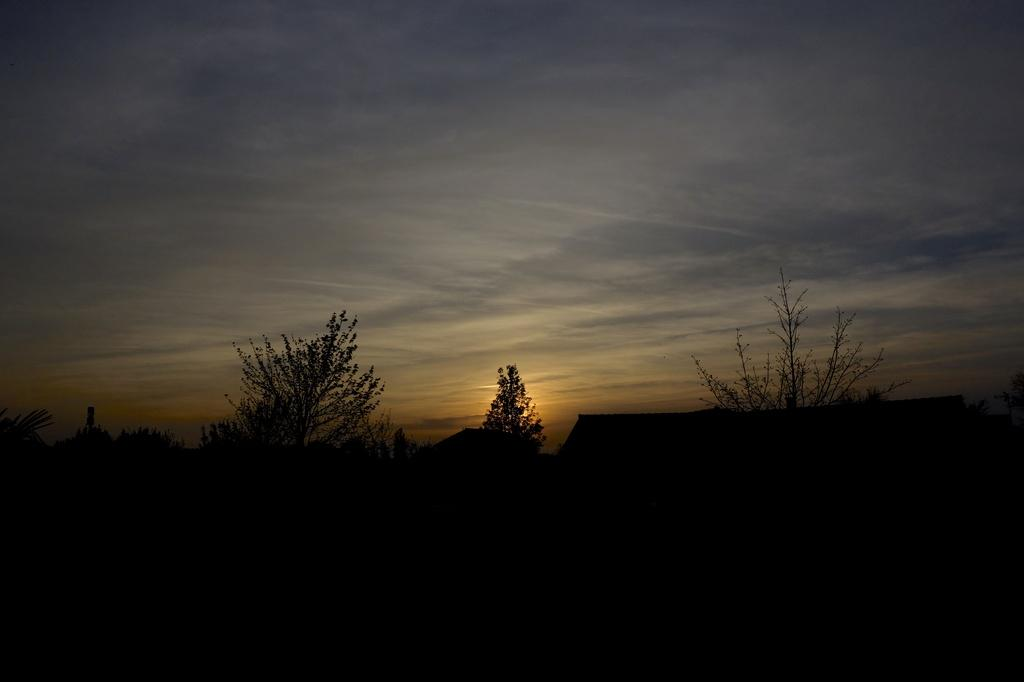What is located at the bottom of the image? There are houses and trees at the bottom of the image. What can be seen in the sky in the image? The sky is visible at the top of the image. When was the image taken? The image was taken during nighttime. What type of foot can be seen in the image? There are no feet visible in the image. Where is the meeting taking place in the image? There is no meeting present in the image. 